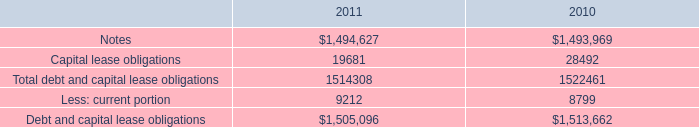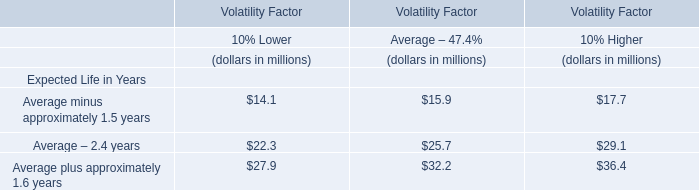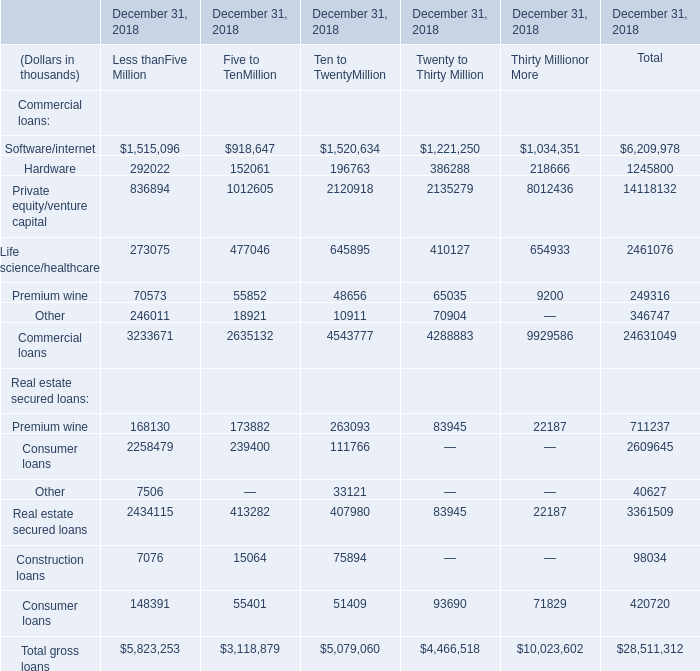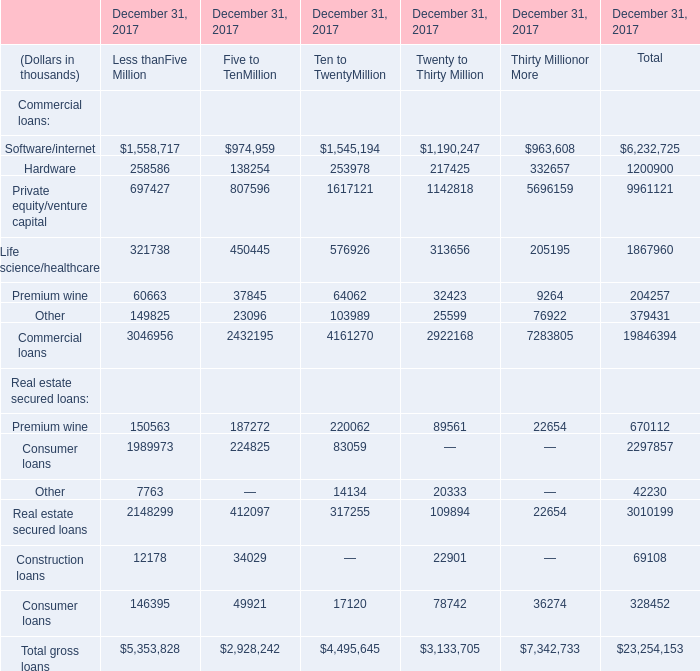What is the sum of Less thanFive Million in 2017 for Commercial loans ? (in thousand) 
Computations: (((((1558717 + 258586) + 697427) + 321738) + 60663) + 149825)
Answer: 3046956.0. 